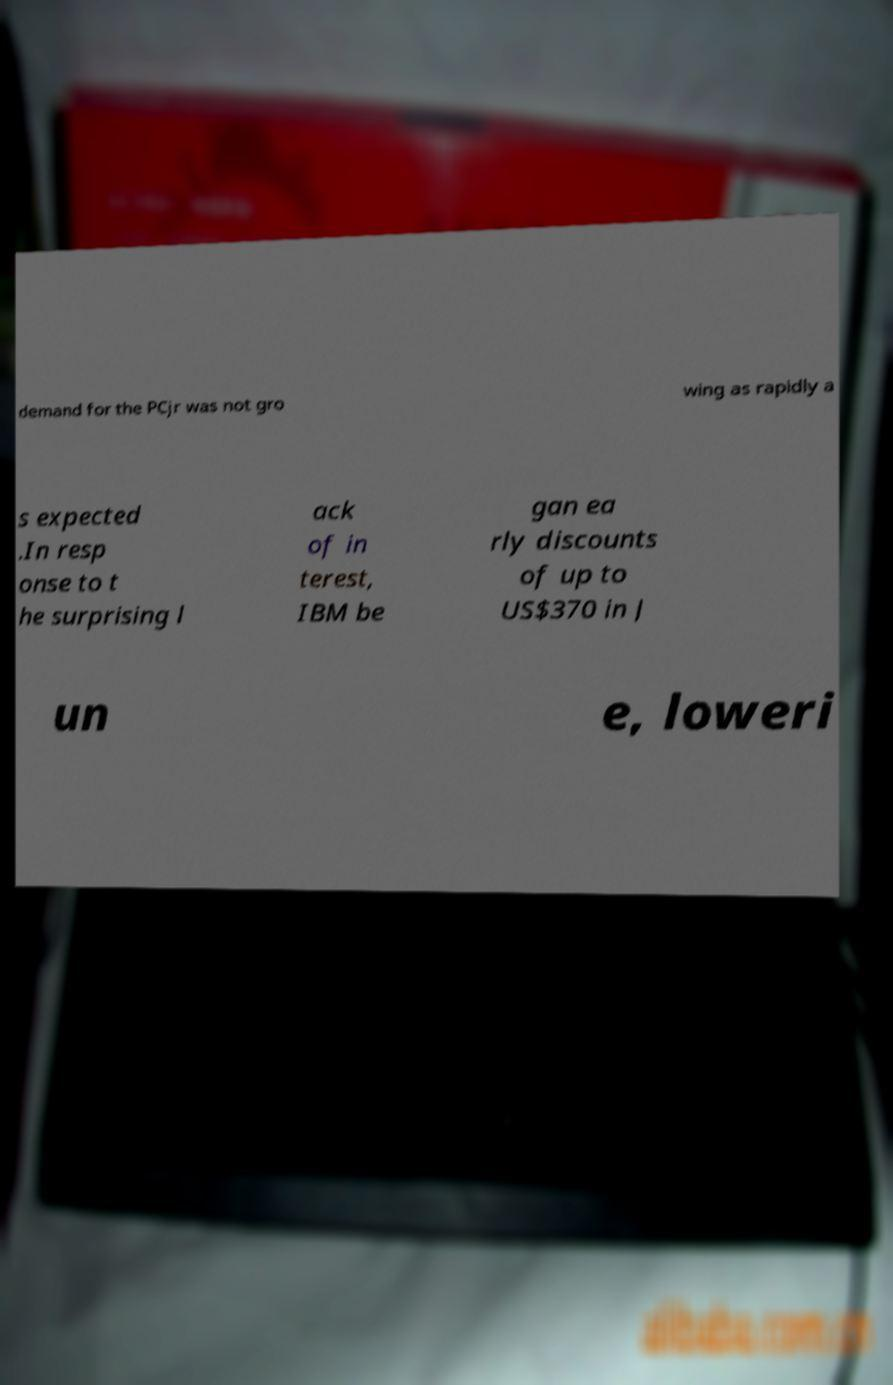For documentation purposes, I need the text within this image transcribed. Could you provide that? demand for the PCjr was not gro wing as rapidly a s expected .In resp onse to t he surprising l ack of in terest, IBM be gan ea rly discounts of up to US$370 in J un e, loweri 